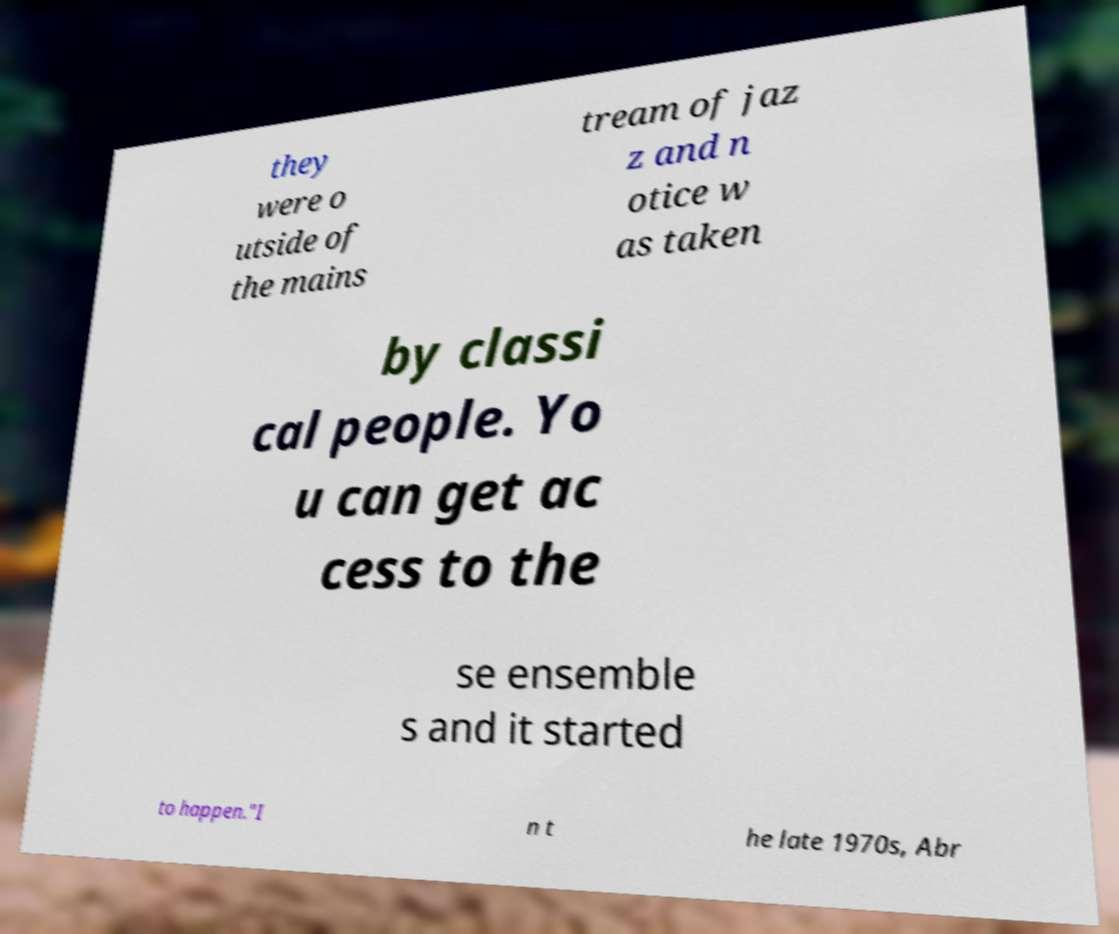For documentation purposes, I need the text within this image transcribed. Could you provide that? they were o utside of the mains tream of jaz z and n otice w as taken by classi cal people. Yo u can get ac cess to the se ensemble s and it started to happen."I n t he late 1970s, Abr 